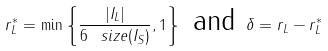Convert formula to latex. <formula><loc_0><loc_0><loc_500><loc_500>r _ { L } ^ { * } = \min \left \{ \frac { | I _ { L } | } { 6 \, \ s i z e ( I _ { S } ) } , 1 \right \} \text { and } \delta = r _ { L } - r _ { L } ^ { * }</formula> 